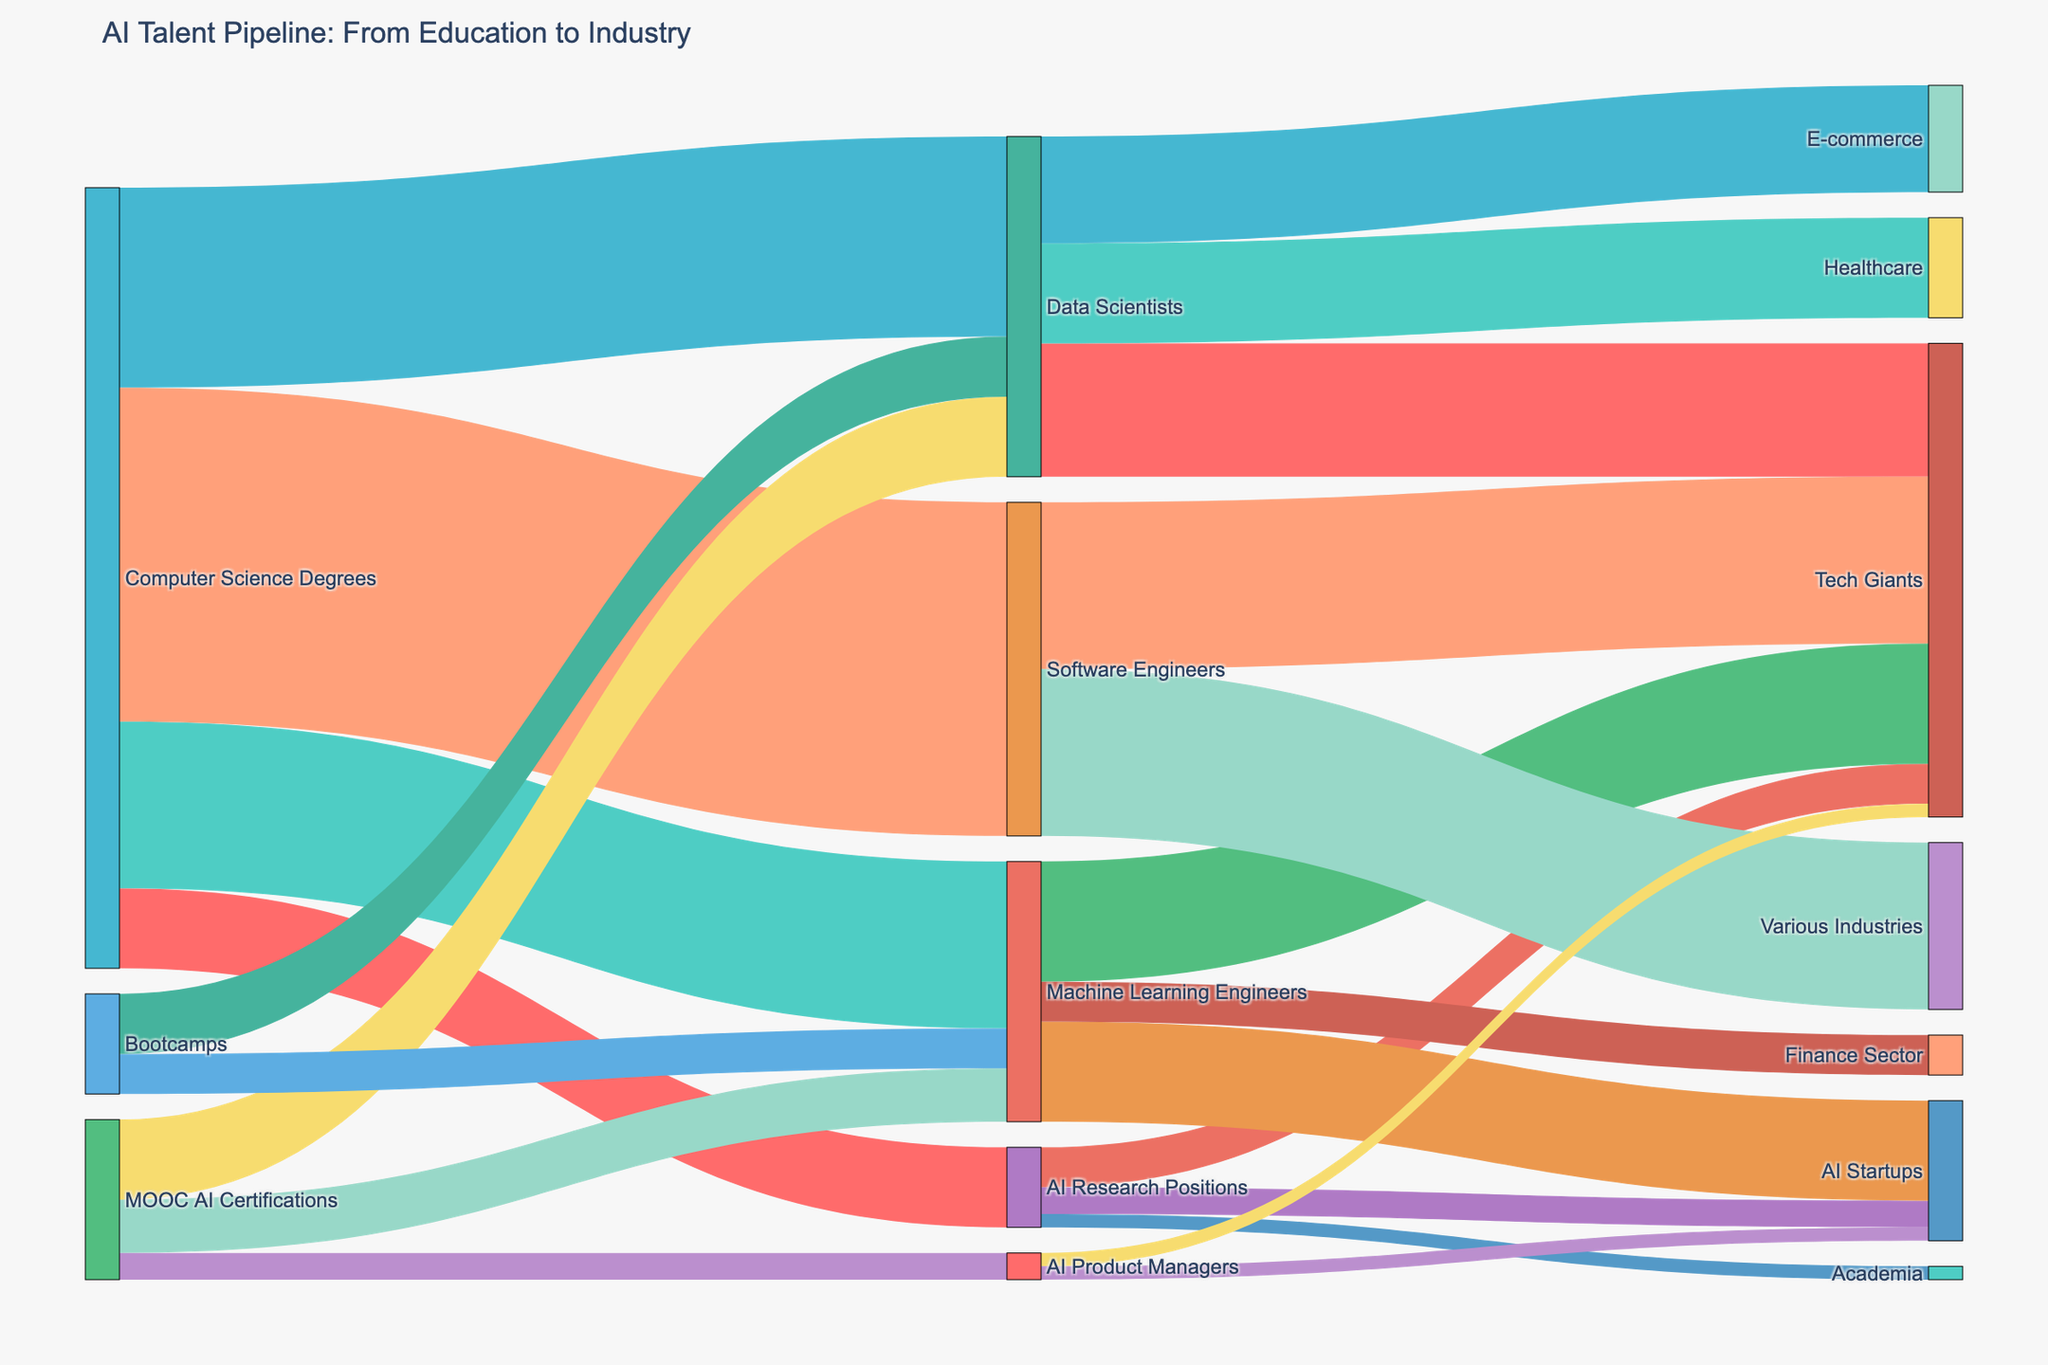What is the title of the Sankey diagram? The title of the Sankey diagram is typically displayed prominently at the top of the figure. It helps the viewer understand the context and main subject of the visualization.
Answer: AI Talent Pipeline: From Education to Industry How many different categories does the Sankey diagram represent? To identify the number of different categories, count all unique nodes (both sources and targets) in the diagram.
Answer: 13 Which category receives the most students from Computer Science Degrees? Look at the links originating from "Computer Science Degrees" and identify which target has the largest value.
Answer: Software Engineers What is the total number of AI Research Positions filled by graduates from Computer Science Degrees? Look for the link where the source is "Computer Science Degrees" and the target is "AI Research Positions," then read the value associated with this link.
Answer: 1200 How many total students from MOOCs enter the AI industry (sum across all related careers)? Add up the values of the links originating from "MOOC AI Certifications" regardless of the target.
Answer: 2400 Which industry sector absorbs the most Data Scientists? Identify the links where the source is "Data Scientists" and determine which target has the highest value.
Answer: Tech Giants How does the number of Data Scientists from Bootcamps compare with those from Computer Science Degrees? Compare the values of the links where the source is "Bootcamps" and "Computer Science Degrees" both targeting "Data Scientists."
Answer: Computer Science Degrees: 3000, Bootcamps: 900 Which career path from AI Research Positions has the least number of individuals? Identify the links originating from "AI Research Positions" and determine which target has the smallest value.
Answer: Academia How many students from Computer Science Degrees become Machine Learning Engineers and end up working in Tech Giants? First, find the value of the link from "Computer Science Degrees" to "Machine Learning Engineers," and then, from "Machine Learning Engineers" to "Tech Giants." Multiply the ratio between the two links' values (1800/2500).
Answer: 1200 How many careers can individuals from MOOC AI Certifications pursue according to the diagram? Count the number of unique targets directly connected to the source "MOOC AI Certifications."
Answer: 3 